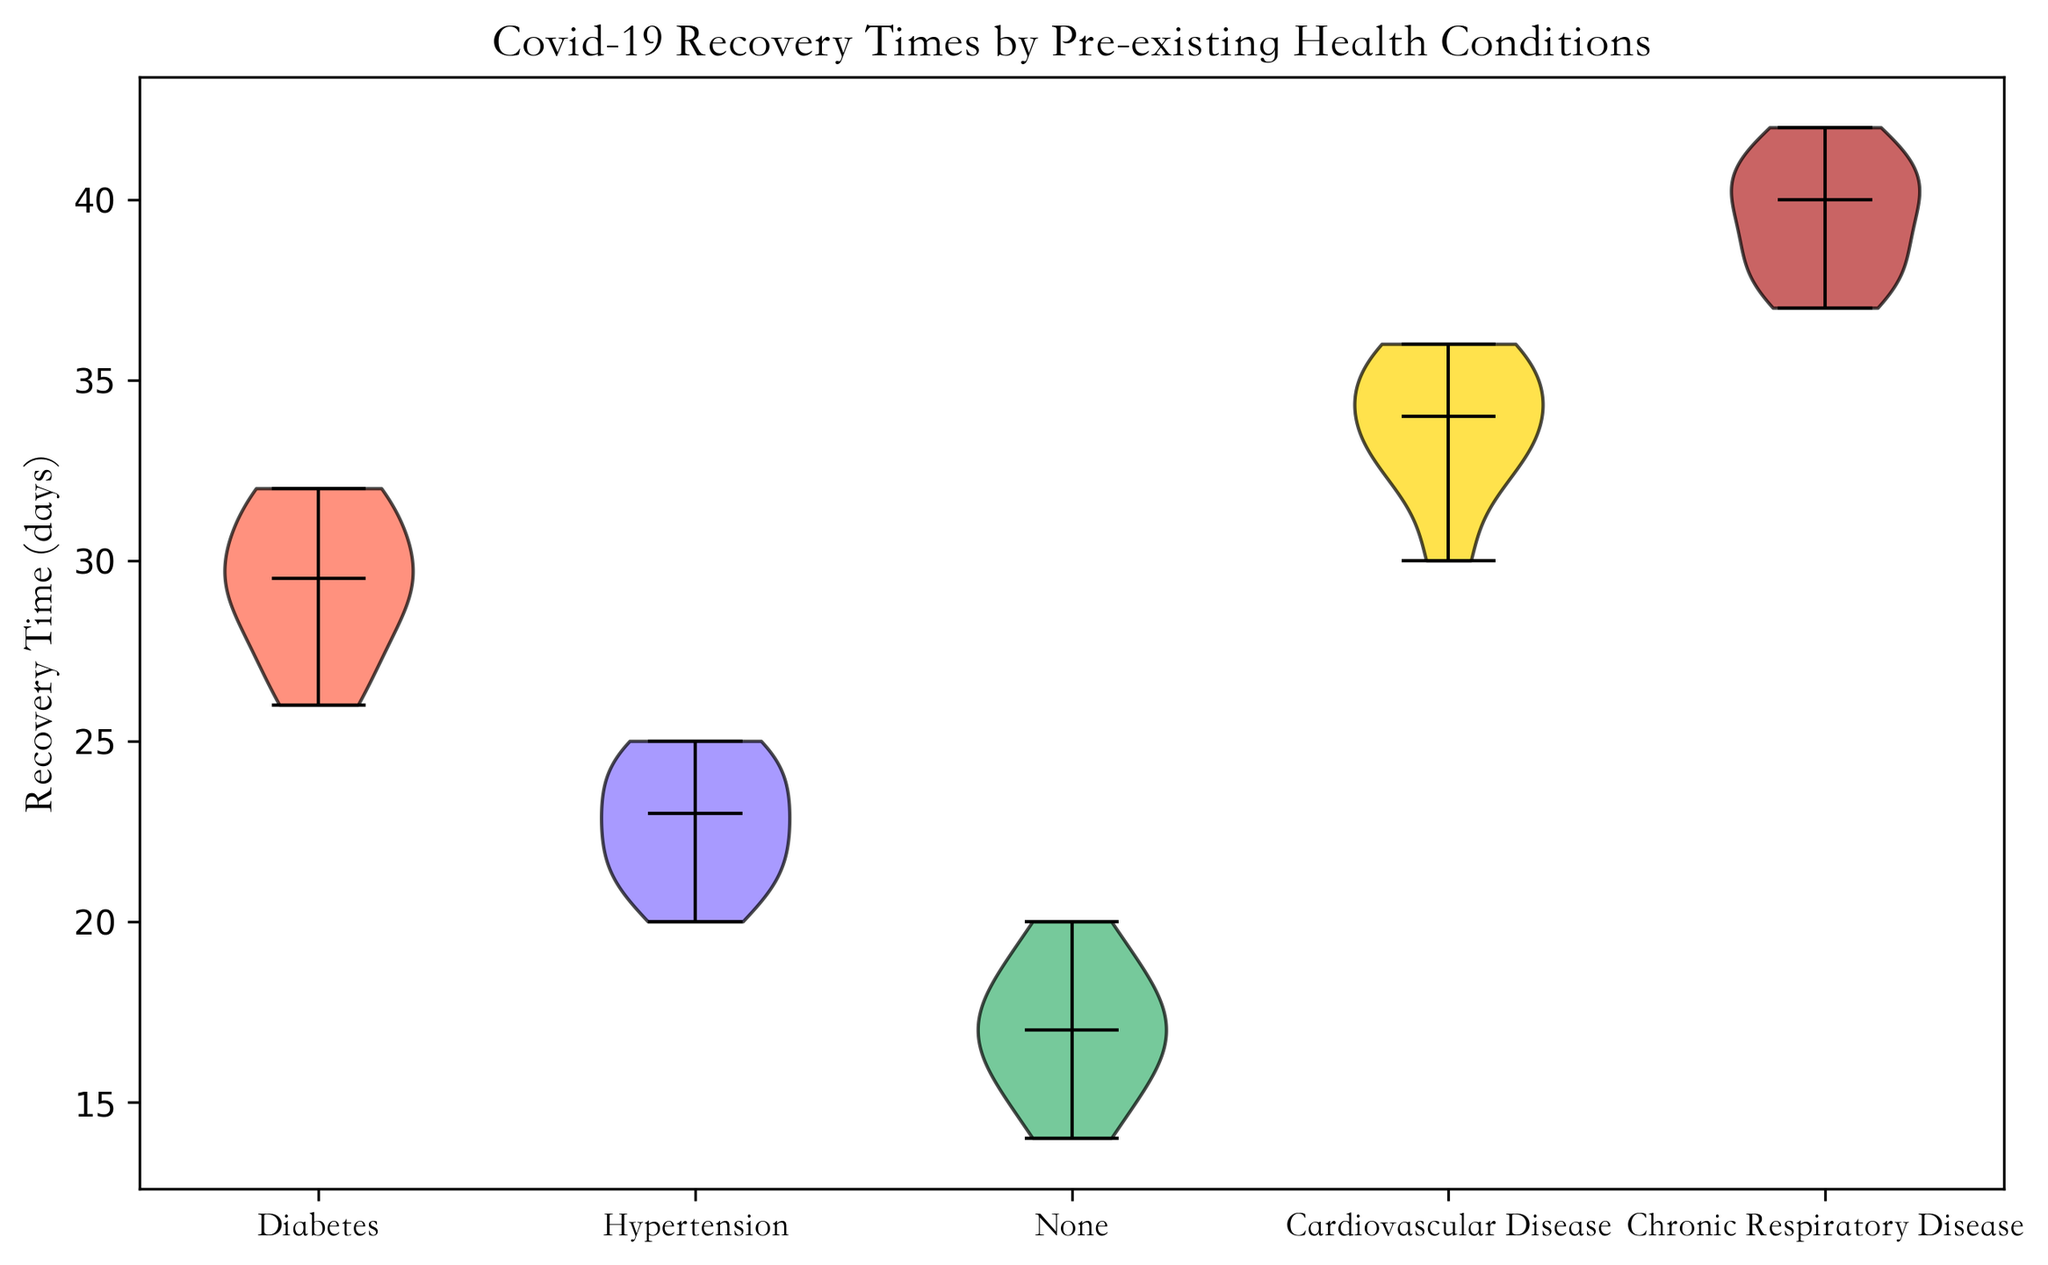Which pre-existing condition has the highest median recovery time? Identify the location of the horizontal median line within each violin plot. The pre-existing condition with the highest median line indicates the highest median recovery time.
Answer: Chronic Respiratory Disease What is the range of recovery times for patients with Diabetes? Look at the lowest and highest points of the shaded area within the Diabetes violin plot. These points represent the minimum and maximum recovery times, respectively.
Answer: 26-32 days Are recovery times for patients with Hypertension generally lower or higher than those for patients with Chronic Respiratory Disease? Compare the median lines: Hypertension's median line is lower than Chronic Respiratory Disease's, showing that Hypertension recovery times are generally lower.
Answer: Lower Which pre-existing condition has the widest spread of recovery times? The width of each violin plot represents the distribution spread. The plot with the widest horizontal span indicates the widest spread.
Answer: Chronic Respiratory Disease How does the recovery time distribution for patients with None pre-existing condition compare to those with Cardiovascular Disease? Compare the shapes and positions of the median lines of both violin plots. None has a lower median value and a narrower spread, indicating generally shorter and more consistent recovery times.
Answer: None has shorter, more consistent recovery times Is there any overlap in the recovery times between patients with Diabetes and those without any pre-existing conditions? Look at the violin plots for Diabetes and None. Check if the shaded areas overlap at any point.
Answer: Yes, there is overlap What is the median recovery time for patients without any pre-existing conditions? Locate the middle horizontal line within the None violin plot. This line represents the median recovery time.
Answer: 16.5 days Which two pre-existing conditions have very similar median recovery times? Observe the horizontal median lines for each condition. Identify which two conditions have median lines that are at close vertical heights.
Answer: Cardiovascular Disease and Hypertension Do patients with Cardiovascular Disease generally have higher or lower recovery times compared to those with Diabetes? Compare the median lines of Cardiovascular Disease and Diabetes. The higher median line indicates generally higher recovery times.
Answer: Higher Which pre-existing condition's recovery times show the least variability? Identify the violin plot with the narrowest range (height of the shaded area) from minimum to maximum recovery times.
Answer: None 